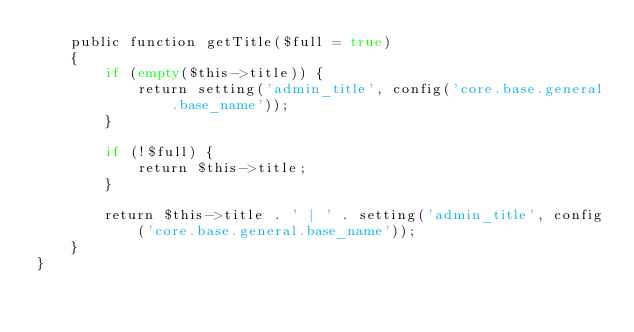<code> <loc_0><loc_0><loc_500><loc_500><_PHP_>    public function getTitle($full = true)
    {
        if (empty($this->title)) {
            return setting('admin_title', config('core.base.general.base_name'));
        }

        if (!$full) {
            return $this->title;
        }

        return $this->title . ' | ' . setting('admin_title', config('core.base.general.base_name'));
    }
}
</code> 